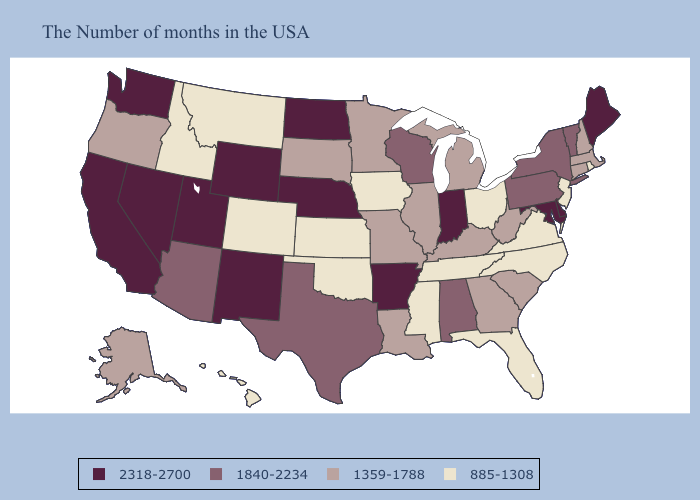Does the first symbol in the legend represent the smallest category?
Be succinct. No. What is the highest value in the Northeast ?
Write a very short answer. 2318-2700. Which states have the lowest value in the Northeast?
Be succinct. Rhode Island, New Jersey. Name the states that have a value in the range 1359-1788?
Give a very brief answer. Massachusetts, New Hampshire, Connecticut, South Carolina, West Virginia, Georgia, Michigan, Kentucky, Illinois, Louisiana, Missouri, Minnesota, South Dakota, Oregon, Alaska. What is the highest value in the Northeast ?
Answer briefly. 2318-2700. Does Indiana have the highest value in the USA?
Concise answer only. Yes. What is the highest value in states that border Montana?
Keep it brief. 2318-2700. What is the value of Kansas?
Quick response, please. 885-1308. Is the legend a continuous bar?
Answer briefly. No. What is the highest value in the USA?
Quick response, please. 2318-2700. Name the states that have a value in the range 1840-2234?
Quick response, please. Vermont, New York, Pennsylvania, Alabama, Wisconsin, Texas, Arizona. Which states hav the highest value in the South?
Be succinct. Delaware, Maryland, Arkansas. Among the states that border South Dakota , which have the highest value?
Keep it brief. Nebraska, North Dakota, Wyoming. Name the states that have a value in the range 1840-2234?
Give a very brief answer. Vermont, New York, Pennsylvania, Alabama, Wisconsin, Texas, Arizona. 